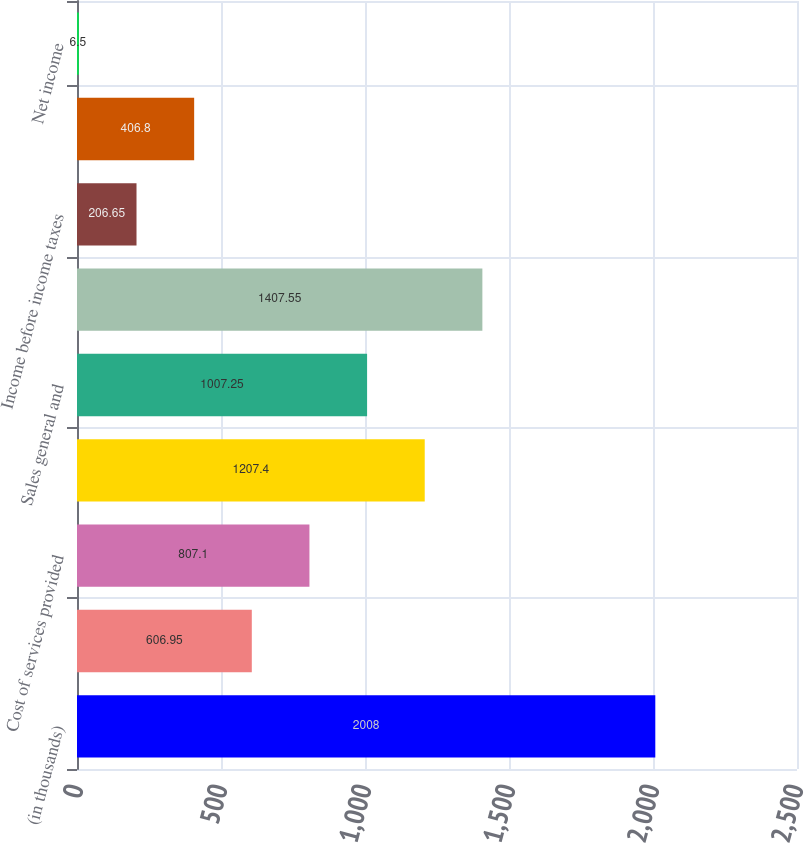<chart> <loc_0><loc_0><loc_500><loc_500><bar_chart><fcel>(in thousands)<fcel>Revenues<fcel>Cost of services provided<fcel>Depreciation and amortization<fcel>Sales general and<fcel>Interest (income)/expense<fcel>Income before income taxes<fcel>Provision for income taxes<fcel>Net income<nl><fcel>2008<fcel>606.95<fcel>807.1<fcel>1207.4<fcel>1007.25<fcel>1407.55<fcel>206.65<fcel>406.8<fcel>6.5<nl></chart> 